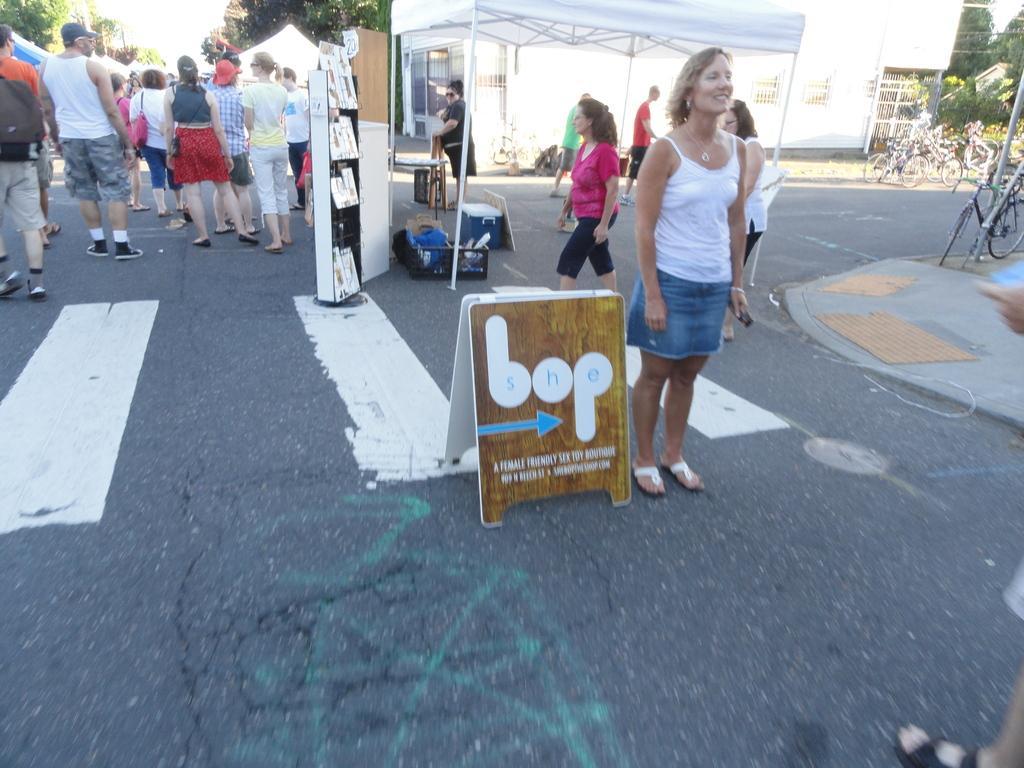Describe this image in one or two sentences. In this image there is a woman who is wearing a white dress standing beside a banner. On the top left corner there is a crowd. On the top right corner we can see a tree and a sky. On the top we can see a building and tent. On the right we can see a bicycle which is stand by a pole. On the bottom corner we can see a leg. 